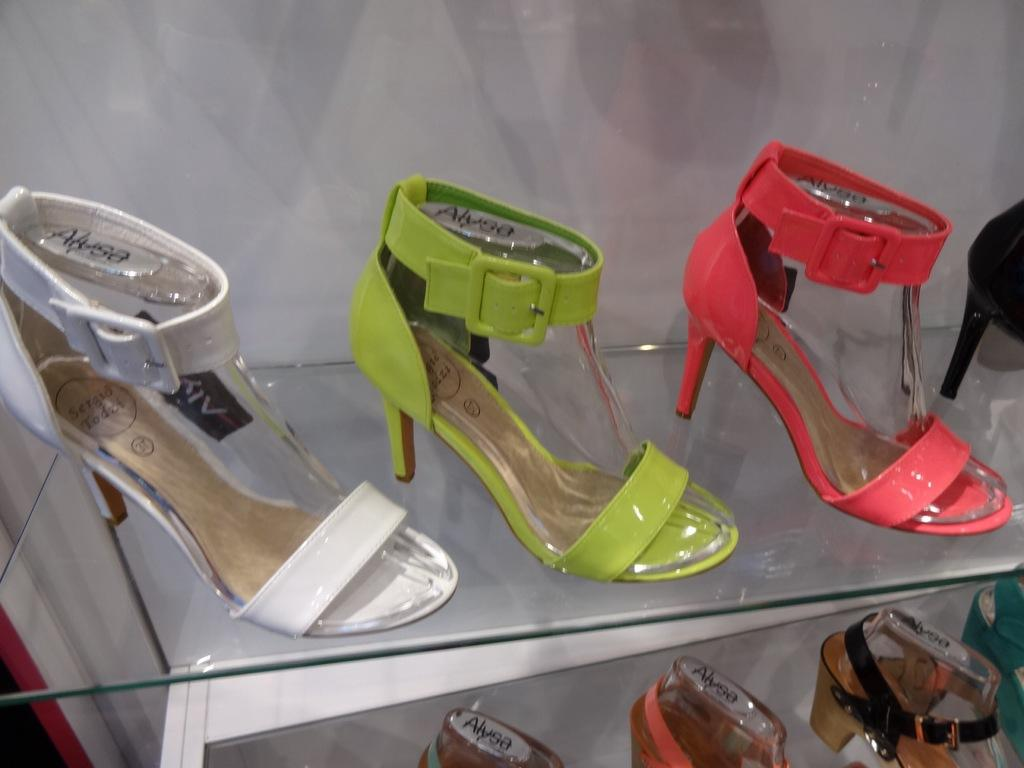<image>
Create a compact narrative representing the image presented. Shoes on a rack with the brand "Alysa" on it. 